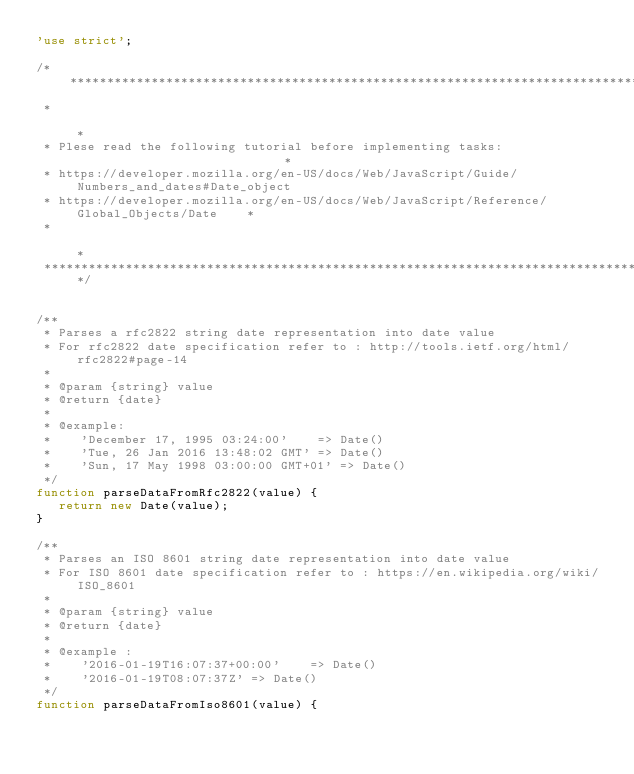Convert code to text. <code><loc_0><loc_0><loc_500><loc_500><_JavaScript_>'use strict';

/********************************************************************************************
 *                                                                                          *
 * Plese read the following tutorial before implementing tasks:                             *
 * https://developer.mozilla.org/en-US/docs/Web/JavaScript/Guide/Numbers_and_dates#Date_object
 * https://developer.mozilla.org/en-US/docs/Web/JavaScript/Reference/Global_Objects/Date    *
 *                                                                                          *
 ********************************************************************************************/


/**
 * Parses a rfc2822 string date representation into date value
 * For rfc2822 date specification refer to : http://tools.ietf.org/html/rfc2822#page-14
 *
 * @param {string} value
 * @return {date}
 *
 * @example:
 *    'December 17, 1995 03:24:00'    => Date()
 *    'Tue, 26 Jan 2016 13:48:02 GMT' => Date()
 *    'Sun, 17 May 1998 03:00:00 GMT+01' => Date()
 */
function parseDataFromRfc2822(value) {
   return new Date(value);
}

/**
 * Parses an ISO 8601 string date representation into date value
 * For ISO 8601 date specification refer to : https://en.wikipedia.org/wiki/ISO_8601
 *
 * @param {string} value
 * @return {date}
 *
 * @example :
 *    '2016-01-19T16:07:37+00:00'    => Date()
 *    '2016-01-19T08:07:37Z' => Date()
 */
function parseDataFromIso8601(value) {</code> 